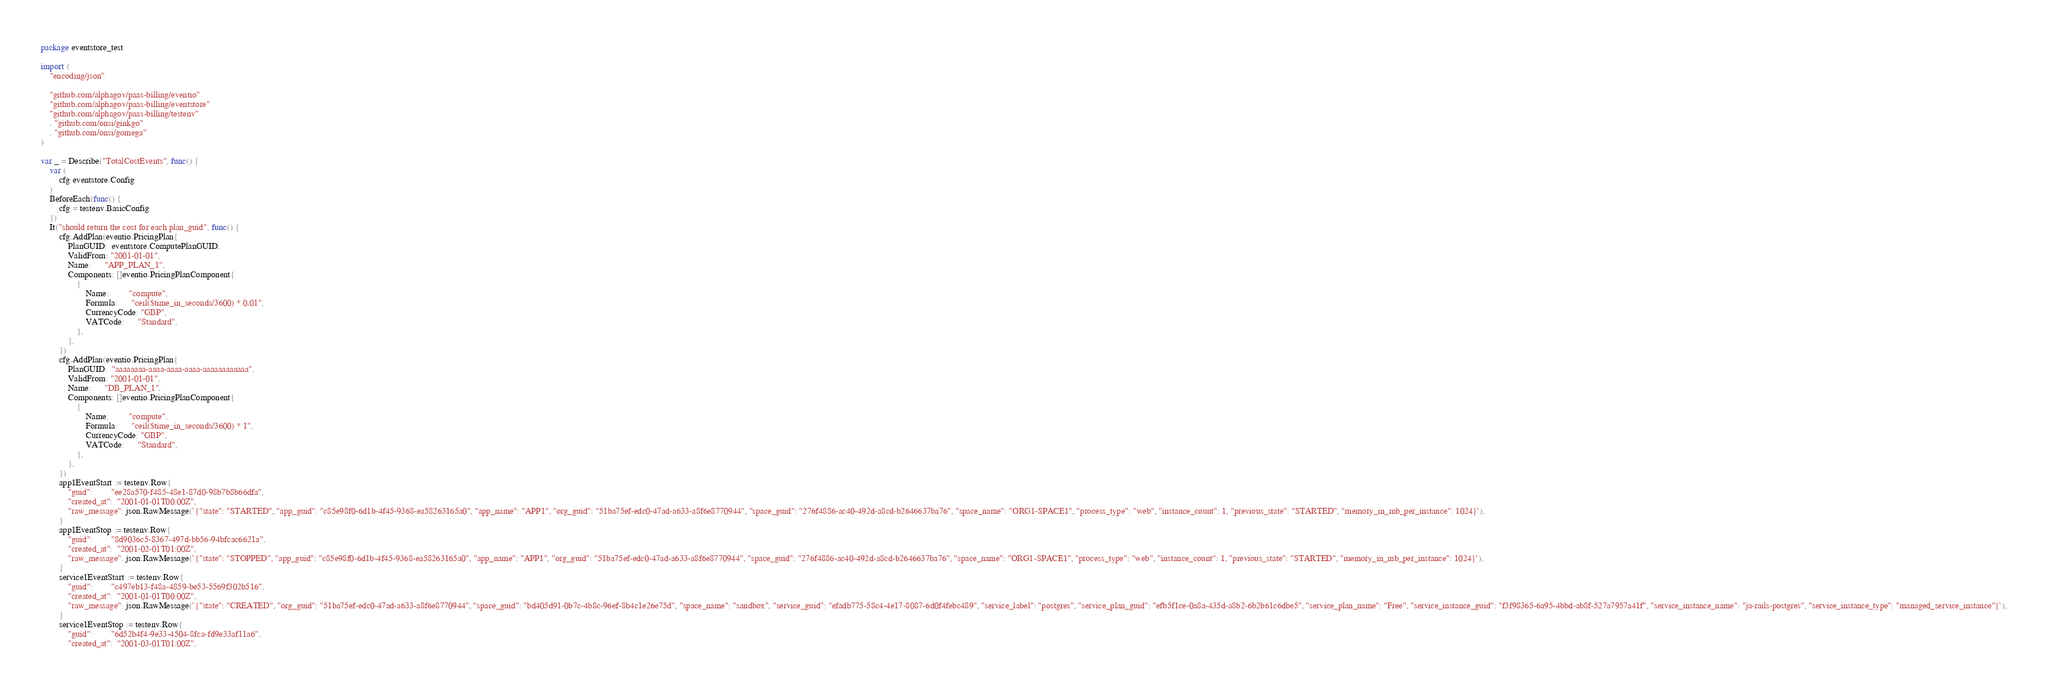Convert code to text. <code><loc_0><loc_0><loc_500><loc_500><_Go_>package eventstore_test

import (
	"encoding/json"

	"github.com/alphagov/paas-billing/eventio"
	"github.com/alphagov/paas-billing/eventstore"
	"github.com/alphagov/paas-billing/testenv"
	. "github.com/onsi/ginkgo"
	. "github.com/onsi/gomega"
)

var _ = Describe("TotalCostEvents", func() {
	var (
		cfg eventstore.Config
	)
	BeforeEach(func() {
		cfg = testenv.BasicConfig
	})
	It("should return the cost for each plan_guid", func() {
		cfg.AddPlan(eventio.PricingPlan{
			PlanGUID:  eventstore.ComputePlanGUID,
			ValidFrom: "2001-01-01",
			Name:      "APP_PLAN_1",
			Components: []eventio.PricingPlanComponent{
				{
					Name:         "compute",
					Formula:      "ceil($time_in_seconds/3600) * 0.01",
					CurrencyCode: "GBP",
					VATCode:      "Standard",
				},
			},
		})
		cfg.AddPlan(eventio.PricingPlan{
			PlanGUID:  "aaaaaaaa-aaaa-aaaa-aaaa-aaaaaaaaaaaa",
			ValidFrom: "2001-01-01",
			Name:      "DB_PLAN_1",
			Components: []eventio.PricingPlanComponent{
				{
					Name:         "compute",
					Formula:      "ceil($time_in_seconds/3600) * 1",
					CurrencyCode: "GBP",
					VATCode:      "Standard",
				},
			},
		})
		app1EventStart := testenv.Row{
			"guid":        "ee28a570-f485-48e1-87d0-98b7b8b66dfa",
			"created_at":  "2001-01-01T00:00Z",
			"raw_message": json.RawMessage(`{"state": "STARTED", "app_guid": "c85e98f0-6d1b-4f45-9368-ea58263165a0", "app_name": "APP1", "org_guid": "51ba75ef-edc0-47ad-a633-a8f6e8770944", "space_guid": "276f4886-ac40-492d-a8cd-b2646637ba76", "space_name": "ORG1-SPACE1", "process_type": "web", "instance_count": 1, "previous_state": "STARTED", "memory_in_mb_per_instance": 1024}`),
		}
		app1EventStop := testenv.Row{
			"guid":        "8d9036c5-8367-497d-bb56-94bfcac6621a",
			"created_at":  "2001-02-01T01:00Z",
			"raw_message": json.RawMessage(`{"state": "STOPPED", "app_guid": "c85e98f0-6d1b-4f45-9368-ea58263165a0", "app_name": "APP1", "org_guid": "51ba75ef-edc0-47ad-a633-a8f6e8770944", "space_guid": "276f4886-ac40-492d-a8cd-b2646637ba76", "space_name": "ORG1-SPACE1", "process_type": "web", "instance_count": 1, "previous_state": "STARTED", "memory_in_mb_per_instance": 1024}`),
		}
		service1EventStart := testenv.Row{
			"guid":        "c497eb13-f48a-4859-be53-5569f302b516",
			"created_at":  "2001-01-01T00:00Z",
			"raw_message": json.RawMessage(`{"state": "CREATED", "org_guid": "51ba75ef-edc0-47ad-a633-a8f6e8770944", "space_guid": "bd405d91-0b7c-4b8c-96ef-8b4c1e26e75d", "space_name": "sandbox", "service_guid": "efadb775-58c4-4e17-8087-6d0f4febc489", "service_label": "postgres", "service_plan_guid": "efb5f1ce-0a8a-435d-a8b2-6b2b61c6dbe5", "service_plan_name": "Free", "service_instance_guid": "f3f98365-6a95-4bbd-ab8f-527a7957a41f", "service_instance_name": "ja-rails-postgres", "service_instance_type": "managed_service_instance"}`),
		}
		service1EventStop := testenv.Row{
			"guid":        "6d52b4f4-9e33-4504-8fca-fd9e33af11a6",
			"created_at":  "2001-03-01T01:00Z",</code> 